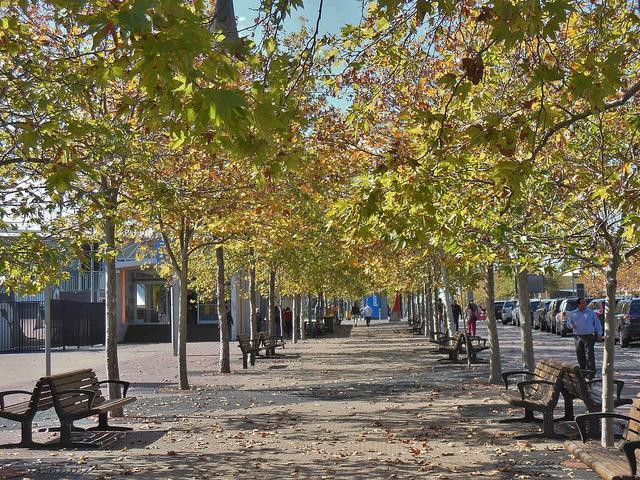What season of the year is it?
Choose the correct response and explain in the format: 'Answer: answer
Rationale: rationale.'
Options: Winter, summer, spring, autumn. Answer: autumn.
Rationale: The season is fall. 